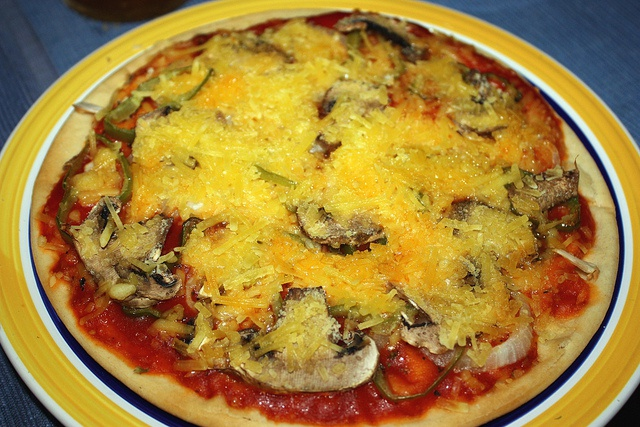Describe the objects in this image and their specific colors. I can see a pizza in black, orange, olive, and maroon tones in this image. 